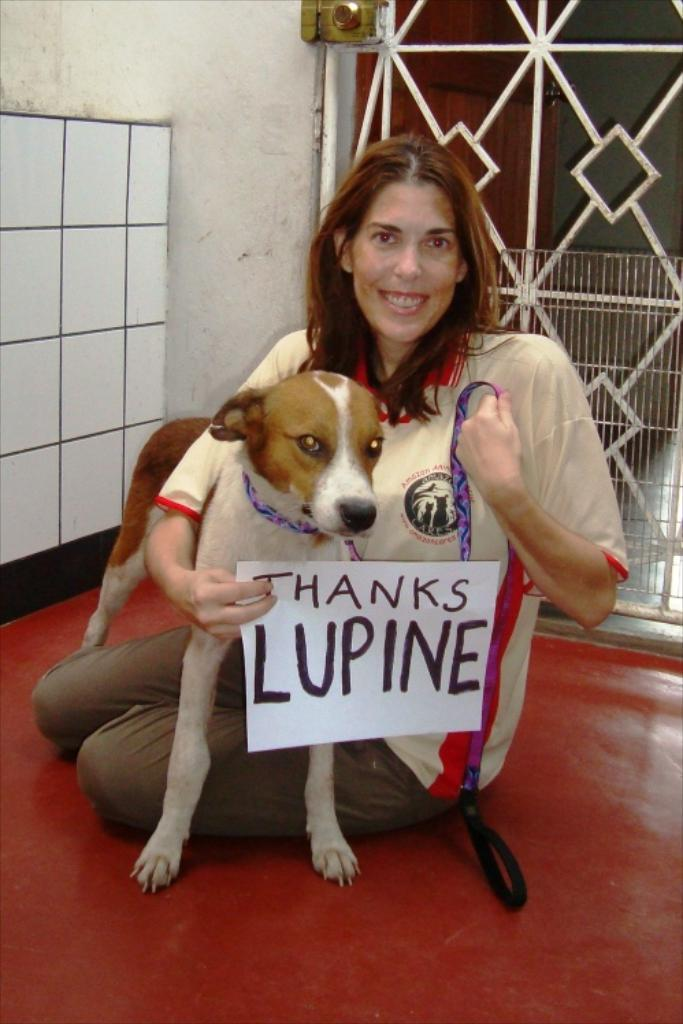Who is the main subject in the image? There is a woman in the image. What is the woman holding in the image? The woman is holding a dog and a paper in her hand. What type of weather can be seen in the image? There is no information about the weather in the image. What type of lettuce is the woman feeding the dog in the image? There is no lettuce present in the image; the woman is holding a dog and a paper. 